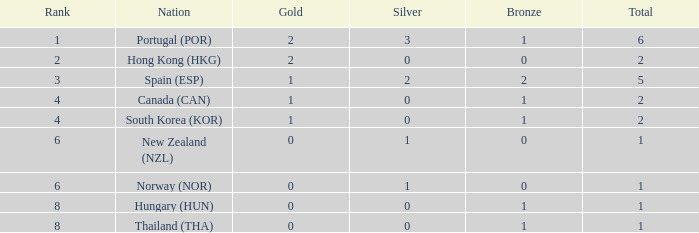At which rank number can you find 0 silver, 2 gold, and a total count below 2? 0.0. 